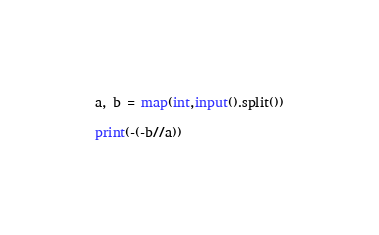Convert code to text. <code><loc_0><loc_0><loc_500><loc_500><_Python_>a, b = map(int,input().split())

print(-(-b//a))</code> 